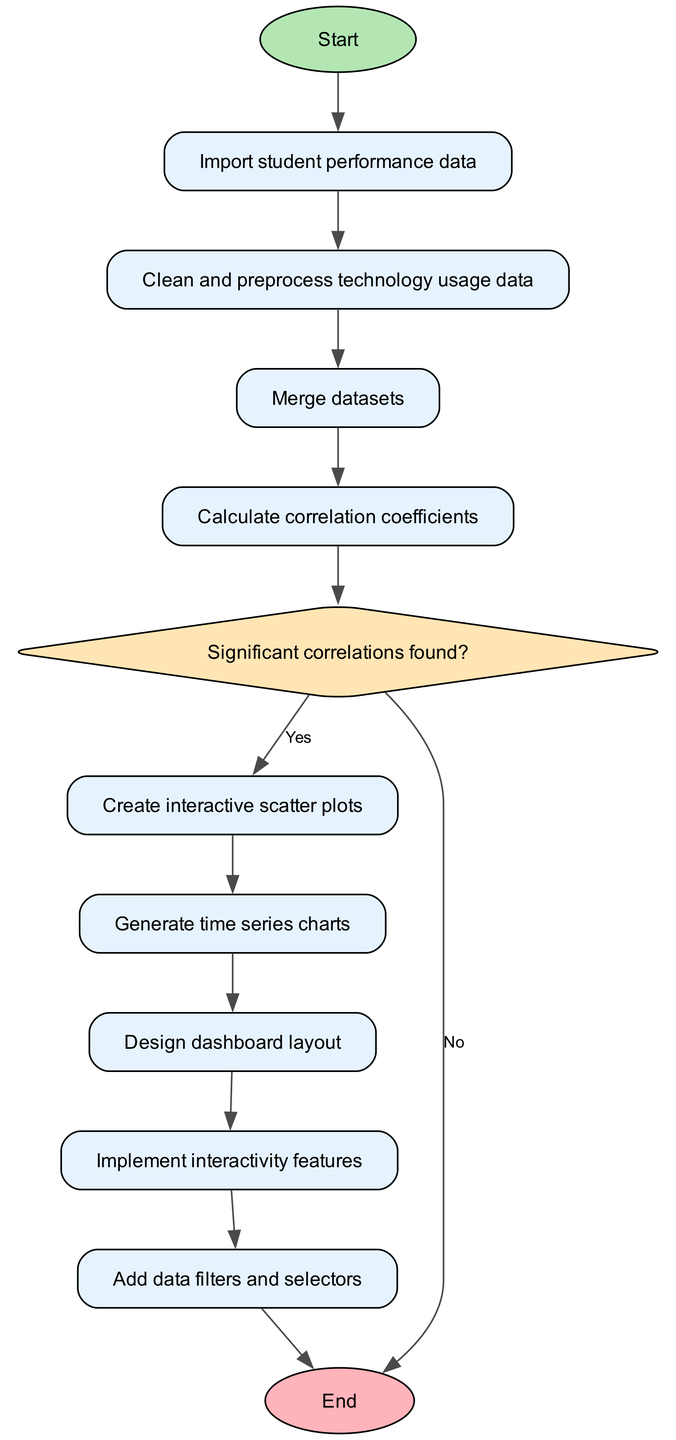What is the first process in the diagram? The first process in the diagram is "Import student performance data" which follows the "Start" node.
Answer: Import student performance data How many processes are present in the diagram? By counting the nodes classified as processes, we find there are six process nodes in total in the flow chart.
Answer: Six What is the output if there are no significant correlations found? If no significant correlations are found, the flow will terminate at the "End" node, bypassing further processes related to visualization.
Answer: End What step follows "Calculate correlation coefficients"? The step that follows "Calculate correlation coefficients" is the decision point, "Significant correlations found?" which determines the next steps based on the outcome.
Answer: Significant correlations found? What is the last action before reaching the "End" node? The last action before reaching the "End" node is "Add data filters and selectors," which allows users to filter and select data within the interactive dashboard.
Answer: Add data filters and selectors Which type of node represents the decision point about significant correlations? The decision point about significant correlations is represented by a diamond-shaped node, indicating that a choice is made at that moment in the process.
Answer: Diamond What action is taken if significant correlations are found? If significant correlations are found, the next action taken is to "Create interactive scatter plots," which visually represents the correlations identified.
Answer: Create interactive scatter plots What type of visualization is generated after creating scatter plots? After creating scatter plots, the next type of visualization generated is "Generate time series charts," providing a different perspective on the data trends over time.
Answer: Generate time series charts 